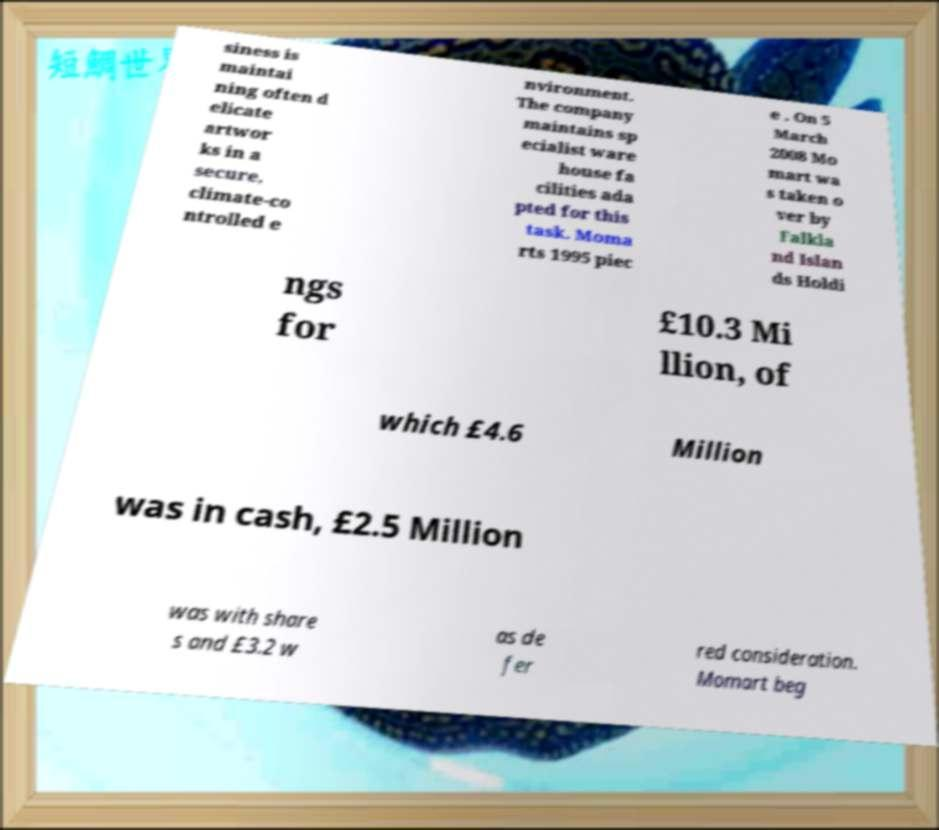Can you read and provide the text displayed in the image?This photo seems to have some interesting text. Can you extract and type it out for me? siness is maintai ning often d elicate artwor ks in a secure, climate-co ntrolled e nvironment. The company maintains sp ecialist ware house fa cilities ada pted for this task. Moma rts 1995 piec e . On 5 March 2008 Mo mart wa s taken o ver by Falkla nd Islan ds Holdi ngs for £10.3 Mi llion, of which £4.6 Million was in cash, £2.5 Million was with share s and £3.2 w as de fer red consideration. Momart beg 